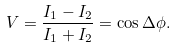Convert formula to latex. <formula><loc_0><loc_0><loc_500><loc_500>V = \frac { I _ { 1 } - I _ { 2 } } { I _ { 1 } + I _ { 2 } } = \cos { \Delta \phi } .</formula> 